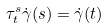<formula> <loc_0><loc_0><loc_500><loc_500>\tau _ { t } ^ { s } \dot { \gamma } ( s ) = \dot { \gamma } ( t )</formula> 